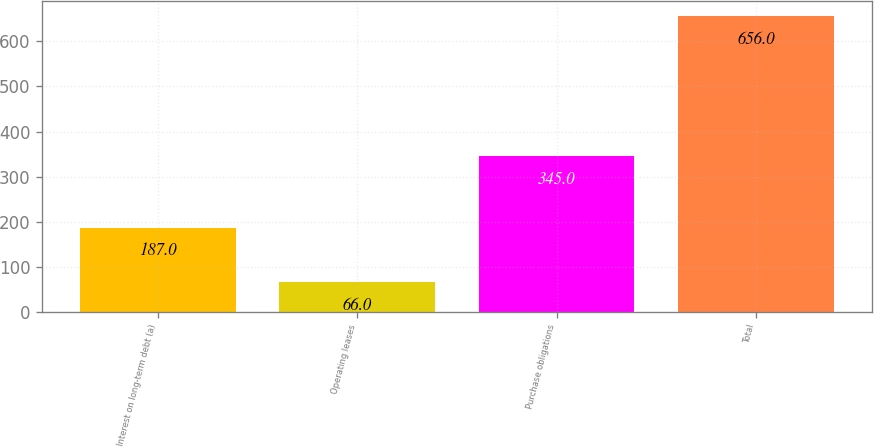<chart> <loc_0><loc_0><loc_500><loc_500><bar_chart><fcel>Interest on long-term debt (a)<fcel>Operating leases<fcel>Purchase obligations<fcel>Total<nl><fcel>187<fcel>66<fcel>345<fcel>656<nl></chart> 